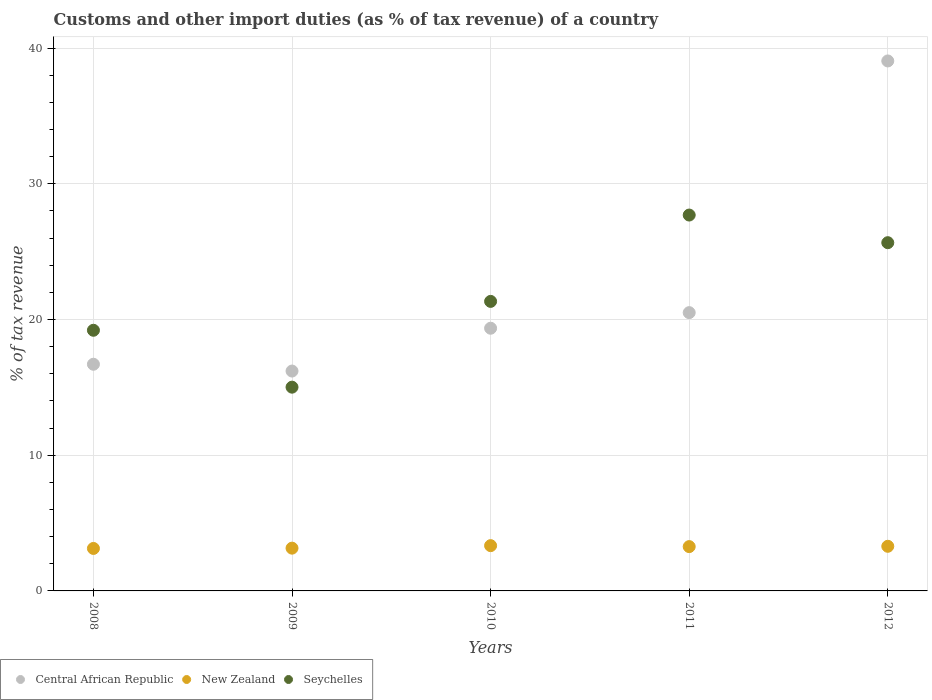How many different coloured dotlines are there?
Provide a succinct answer. 3. Is the number of dotlines equal to the number of legend labels?
Make the answer very short. Yes. What is the percentage of tax revenue from customs in Seychelles in 2011?
Provide a succinct answer. 27.7. Across all years, what is the maximum percentage of tax revenue from customs in New Zealand?
Your answer should be compact. 3.34. Across all years, what is the minimum percentage of tax revenue from customs in Central African Republic?
Provide a short and direct response. 16.2. In which year was the percentage of tax revenue from customs in Central African Republic minimum?
Provide a succinct answer. 2009. What is the total percentage of tax revenue from customs in Seychelles in the graph?
Offer a terse response. 108.92. What is the difference between the percentage of tax revenue from customs in Seychelles in 2010 and that in 2012?
Your answer should be very brief. -4.33. What is the difference between the percentage of tax revenue from customs in Central African Republic in 2010 and the percentage of tax revenue from customs in New Zealand in 2008?
Provide a short and direct response. 16.23. What is the average percentage of tax revenue from customs in Seychelles per year?
Give a very brief answer. 21.78. In the year 2012, what is the difference between the percentage of tax revenue from customs in Central African Republic and percentage of tax revenue from customs in Seychelles?
Provide a succinct answer. 13.39. What is the ratio of the percentage of tax revenue from customs in Central African Republic in 2008 to that in 2011?
Keep it short and to the point. 0.81. What is the difference between the highest and the second highest percentage of tax revenue from customs in Seychelles?
Give a very brief answer. 2.04. What is the difference between the highest and the lowest percentage of tax revenue from customs in Seychelles?
Offer a terse response. 12.68. In how many years, is the percentage of tax revenue from customs in Seychelles greater than the average percentage of tax revenue from customs in Seychelles taken over all years?
Your answer should be very brief. 2. Is the sum of the percentage of tax revenue from customs in New Zealand in 2009 and 2011 greater than the maximum percentage of tax revenue from customs in Seychelles across all years?
Your response must be concise. No. Is it the case that in every year, the sum of the percentage of tax revenue from customs in Seychelles and percentage of tax revenue from customs in New Zealand  is greater than the percentage of tax revenue from customs in Central African Republic?
Give a very brief answer. No. Does the percentage of tax revenue from customs in New Zealand monotonically increase over the years?
Offer a terse response. No. Is the percentage of tax revenue from customs in Central African Republic strictly greater than the percentage of tax revenue from customs in New Zealand over the years?
Ensure brevity in your answer.  Yes. How many dotlines are there?
Your answer should be compact. 3. Does the graph contain any zero values?
Ensure brevity in your answer.  No. Where does the legend appear in the graph?
Your answer should be compact. Bottom left. How are the legend labels stacked?
Your response must be concise. Horizontal. What is the title of the graph?
Your answer should be very brief. Customs and other import duties (as % of tax revenue) of a country. Does "French Polynesia" appear as one of the legend labels in the graph?
Your answer should be compact. No. What is the label or title of the X-axis?
Ensure brevity in your answer.  Years. What is the label or title of the Y-axis?
Your answer should be very brief. % of tax revenue. What is the % of tax revenue of Central African Republic in 2008?
Offer a terse response. 16.7. What is the % of tax revenue of New Zealand in 2008?
Offer a terse response. 3.13. What is the % of tax revenue of Seychelles in 2008?
Make the answer very short. 19.21. What is the % of tax revenue of Central African Republic in 2009?
Give a very brief answer. 16.2. What is the % of tax revenue of New Zealand in 2009?
Your answer should be compact. 3.15. What is the % of tax revenue in Seychelles in 2009?
Offer a terse response. 15.01. What is the % of tax revenue of Central African Republic in 2010?
Your response must be concise. 19.36. What is the % of tax revenue of New Zealand in 2010?
Offer a very short reply. 3.34. What is the % of tax revenue of Seychelles in 2010?
Provide a succinct answer. 21.34. What is the % of tax revenue in Central African Republic in 2011?
Provide a short and direct response. 20.51. What is the % of tax revenue of New Zealand in 2011?
Your answer should be very brief. 3.27. What is the % of tax revenue in Seychelles in 2011?
Your response must be concise. 27.7. What is the % of tax revenue in Central African Republic in 2012?
Provide a succinct answer. 39.05. What is the % of tax revenue in New Zealand in 2012?
Your answer should be compact. 3.29. What is the % of tax revenue in Seychelles in 2012?
Make the answer very short. 25.66. Across all years, what is the maximum % of tax revenue in Central African Republic?
Your answer should be compact. 39.05. Across all years, what is the maximum % of tax revenue in New Zealand?
Your answer should be compact. 3.34. Across all years, what is the maximum % of tax revenue of Seychelles?
Provide a short and direct response. 27.7. Across all years, what is the minimum % of tax revenue in Central African Republic?
Your answer should be very brief. 16.2. Across all years, what is the minimum % of tax revenue in New Zealand?
Provide a short and direct response. 3.13. Across all years, what is the minimum % of tax revenue of Seychelles?
Your answer should be compact. 15.01. What is the total % of tax revenue of Central African Republic in the graph?
Keep it short and to the point. 111.82. What is the total % of tax revenue of New Zealand in the graph?
Your response must be concise. 16.17. What is the total % of tax revenue in Seychelles in the graph?
Ensure brevity in your answer.  108.92. What is the difference between the % of tax revenue in Central African Republic in 2008 and that in 2009?
Your response must be concise. 0.5. What is the difference between the % of tax revenue in New Zealand in 2008 and that in 2009?
Provide a succinct answer. -0.02. What is the difference between the % of tax revenue of Seychelles in 2008 and that in 2009?
Give a very brief answer. 4.19. What is the difference between the % of tax revenue of Central African Republic in 2008 and that in 2010?
Provide a succinct answer. -2.65. What is the difference between the % of tax revenue in New Zealand in 2008 and that in 2010?
Give a very brief answer. -0.21. What is the difference between the % of tax revenue of Seychelles in 2008 and that in 2010?
Your answer should be very brief. -2.13. What is the difference between the % of tax revenue in Central African Republic in 2008 and that in 2011?
Your answer should be compact. -3.8. What is the difference between the % of tax revenue of New Zealand in 2008 and that in 2011?
Provide a short and direct response. -0.14. What is the difference between the % of tax revenue of Seychelles in 2008 and that in 2011?
Your answer should be very brief. -8.49. What is the difference between the % of tax revenue in Central African Republic in 2008 and that in 2012?
Give a very brief answer. -22.35. What is the difference between the % of tax revenue in New Zealand in 2008 and that in 2012?
Ensure brevity in your answer.  -0.16. What is the difference between the % of tax revenue of Seychelles in 2008 and that in 2012?
Offer a very short reply. -6.45. What is the difference between the % of tax revenue in Central African Republic in 2009 and that in 2010?
Provide a short and direct response. -3.16. What is the difference between the % of tax revenue of New Zealand in 2009 and that in 2010?
Offer a terse response. -0.18. What is the difference between the % of tax revenue in Seychelles in 2009 and that in 2010?
Give a very brief answer. -6.32. What is the difference between the % of tax revenue in Central African Republic in 2009 and that in 2011?
Your answer should be compact. -4.3. What is the difference between the % of tax revenue of New Zealand in 2009 and that in 2011?
Offer a very short reply. -0.11. What is the difference between the % of tax revenue of Seychelles in 2009 and that in 2011?
Provide a succinct answer. -12.68. What is the difference between the % of tax revenue in Central African Republic in 2009 and that in 2012?
Make the answer very short. -22.85. What is the difference between the % of tax revenue of New Zealand in 2009 and that in 2012?
Make the answer very short. -0.14. What is the difference between the % of tax revenue in Seychelles in 2009 and that in 2012?
Provide a short and direct response. -10.65. What is the difference between the % of tax revenue of Central African Republic in 2010 and that in 2011?
Ensure brevity in your answer.  -1.15. What is the difference between the % of tax revenue in New Zealand in 2010 and that in 2011?
Your response must be concise. 0.07. What is the difference between the % of tax revenue in Seychelles in 2010 and that in 2011?
Provide a succinct answer. -6.36. What is the difference between the % of tax revenue of Central African Republic in 2010 and that in 2012?
Your response must be concise. -19.7. What is the difference between the % of tax revenue in New Zealand in 2010 and that in 2012?
Offer a very short reply. 0.05. What is the difference between the % of tax revenue in Seychelles in 2010 and that in 2012?
Offer a terse response. -4.33. What is the difference between the % of tax revenue in Central African Republic in 2011 and that in 2012?
Provide a succinct answer. -18.55. What is the difference between the % of tax revenue in New Zealand in 2011 and that in 2012?
Ensure brevity in your answer.  -0.02. What is the difference between the % of tax revenue in Seychelles in 2011 and that in 2012?
Ensure brevity in your answer.  2.04. What is the difference between the % of tax revenue of Central African Republic in 2008 and the % of tax revenue of New Zealand in 2009?
Make the answer very short. 13.55. What is the difference between the % of tax revenue of Central African Republic in 2008 and the % of tax revenue of Seychelles in 2009?
Make the answer very short. 1.69. What is the difference between the % of tax revenue in New Zealand in 2008 and the % of tax revenue in Seychelles in 2009?
Offer a terse response. -11.88. What is the difference between the % of tax revenue in Central African Republic in 2008 and the % of tax revenue in New Zealand in 2010?
Provide a succinct answer. 13.37. What is the difference between the % of tax revenue in Central African Republic in 2008 and the % of tax revenue in Seychelles in 2010?
Offer a very short reply. -4.63. What is the difference between the % of tax revenue of New Zealand in 2008 and the % of tax revenue of Seychelles in 2010?
Offer a terse response. -18.21. What is the difference between the % of tax revenue of Central African Republic in 2008 and the % of tax revenue of New Zealand in 2011?
Give a very brief answer. 13.44. What is the difference between the % of tax revenue in Central African Republic in 2008 and the % of tax revenue in Seychelles in 2011?
Provide a succinct answer. -10.99. What is the difference between the % of tax revenue of New Zealand in 2008 and the % of tax revenue of Seychelles in 2011?
Your response must be concise. -24.57. What is the difference between the % of tax revenue in Central African Republic in 2008 and the % of tax revenue in New Zealand in 2012?
Offer a very short reply. 13.41. What is the difference between the % of tax revenue in Central African Republic in 2008 and the % of tax revenue in Seychelles in 2012?
Provide a succinct answer. -8.96. What is the difference between the % of tax revenue of New Zealand in 2008 and the % of tax revenue of Seychelles in 2012?
Offer a terse response. -22.53. What is the difference between the % of tax revenue of Central African Republic in 2009 and the % of tax revenue of New Zealand in 2010?
Your answer should be very brief. 12.87. What is the difference between the % of tax revenue in Central African Republic in 2009 and the % of tax revenue in Seychelles in 2010?
Make the answer very short. -5.13. What is the difference between the % of tax revenue in New Zealand in 2009 and the % of tax revenue in Seychelles in 2010?
Offer a terse response. -18.18. What is the difference between the % of tax revenue in Central African Republic in 2009 and the % of tax revenue in New Zealand in 2011?
Keep it short and to the point. 12.94. What is the difference between the % of tax revenue of Central African Republic in 2009 and the % of tax revenue of Seychelles in 2011?
Make the answer very short. -11.5. What is the difference between the % of tax revenue of New Zealand in 2009 and the % of tax revenue of Seychelles in 2011?
Your answer should be very brief. -24.55. What is the difference between the % of tax revenue of Central African Republic in 2009 and the % of tax revenue of New Zealand in 2012?
Offer a very short reply. 12.91. What is the difference between the % of tax revenue in Central African Republic in 2009 and the % of tax revenue in Seychelles in 2012?
Your answer should be very brief. -9.46. What is the difference between the % of tax revenue in New Zealand in 2009 and the % of tax revenue in Seychelles in 2012?
Provide a succinct answer. -22.51. What is the difference between the % of tax revenue of Central African Republic in 2010 and the % of tax revenue of New Zealand in 2011?
Your answer should be very brief. 16.09. What is the difference between the % of tax revenue of Central African Republic in 2010 and the % of tax revenue of Seychelles in 2011?
Your answer should be compact. -8.34. What is the difference between the % of tax revenue of New Zealand in 2010 and the % of tax revenue of Seychelles in 2011?
Keep it short and to the point. -24.36. What is the difference between the % of tax revenue in Central African Republic in 2010 and the % of tax revenue in New Zealand in 2012?
Give a very brief answer. 16.07. What is the difference between the % of tax revenue in Central African Republic in 2010 and the % of tax revenue in Seychelles in 2012?
Your answer should be compact. -6.3. What is the difference between the % of tax revenue in New Zealand in 2010 and the % of tax revenue in Seychelles in 2012?
Your response must be concise. -22.33. What is the difference between the % of tax revenue of Central African Republic in 2011 and the % of tax revenue of New Zealand in 2012?
Provide a succinct answer. 17.22. What is the difference between the % of tax revenue in Central African Republic in 2011 and the % of tax revenue in Seychelles in 2012?
Give a very brief answer. -5.15. What is the difference between the % of tax revenue of New Zealand in 2011 and the % of tax revenue of Seychelles in 2012?
Offer a very short reply. -22.4. What is the average % of tax revenue in Central African Republic per year?
Give a very brief answer. 22.36. What is the average % of tax revenue in New Zealand per year?
Offer a very short reply. 3.23. What is the average % of tax revenue in Seychelles per year?
Provide a succinct answer. 21.78. In the year 2008, what is the difference between the % of tax revenue in Central African Republic and % of tax revenue in New Zealand?
Provide a succinct answer. 13.57. In the year 2008, what is the difference between the % of tax revenue of Central African Republic and % of tax revenue of Seychelles?
Your answer should be very brief. -2.5. In the year 2008, what is the difference between the % of tax revenue of New Zealand and % of tax revenue of Seychelles?
Make the answer very short. -16.08. In the year 2009, what is the difference between the % of tax revenue of Central African Republic and % of tax revenue of New Zealand?
Ensure brevity in your answer.  13.05. In the year 2009, what is the difference between the % of tax revenue in Central African Republic and % of tax revenue in Seychelles?
Give a very brief answer. 1.19. In the year 2009, what is the difference between the % of tax revenue in New Zealand and % of tax revenue in Seychelles?
Ensure brevity in your answer.  -11.86. In the year 2010, what is the difference between the % of tax revenue of Central African Republic and % of tax revenue of New Zealand?
Your answer should be compact. 16.02. In the year 2010, what is the difference between the % of tax revenue in Central African Republic and % of tax revenue in Seychelles?
Ensure brevity in your answer.  -1.98. In the year 2010, what is the difference between the % of tax revenue of New Zealand and % of tax revenue of Seychelles?
Give a very brief answer. -18. In the year 2011, what is the difference between the % of tax revenue of Central African Republic and % of tax revenue of New Zealand?
Your answer should be very brief. 17.24. In the year 2011, what is the difference between the % of tax revenue in Central African Republic and % of tax revenue in Seychelles?
Offer a very short reply. -7.19. In the year 2011, what is the difference between the % of tax revenue in New Zealand and % of tax revenue in Seychelles?
Provide a short and direct response. -24.43. In the year 2012, what is the difference between the % of tax revenue of Central African Republic and % of tax revenue of New Zealand?
Offer a terse response. 35.76. In the year 2012, what is the difference between the % of tax revenue in Central African Republic and % of tax revenue in Seychelles?
Your answer should be compact. 13.39. In the year 2012, what is the difference between the % of tax revenue in New Zealand and % of tax revenue in Seychelles?
Keep it short and to the point. -22.37. What is the ratio of the % of tax revenue of Central African Republic in 2008 to that in 2009?
Give a very brief answer. 1.03. What is the ratio of the % of tax revenue of New Zealand in 2008 to that in 2009?
Give a very brief answer. 0.99. What is the ratio of the % of tax revenue of Seychelles in 2008 to that in 2009?
Your answer should be very brief. 1.28. What is the ratio of the % of tax revenue of Central African Republic in 2008 to that in 2010?
Your response must be concise. 0.86. What is the ratio of the % of tax revenue of New Zealand in 2008 to that in 2010?
Provide a short and direct response. 0.94. What is the ratio of the % of tax revenue in Seychelles in 2008 to that in 2010?
Keep it short and to the point. 0.9. What is the ratio of the % of tax revenue in Central African Republic in 2008 to that in 2011?
Give a very brief answer. 0.81. What is the ratio of the % of tax revenue in New Zealand in 2008 to that in 2011?
Provide a succinct answer. 0.96. What is the ratio of the % of tax revenue of Seychelles in 2008 to that in 2011?
Give a very brief answer. 0.69. What is the ratio of the % of tax revenue in Central African Republic in 2008 to that in 2012?
Make the answer very short. 0.43. What is the ratio of the % of tax revenue of New Zealand in 2008 to that in 2012?
Your answer should be compact. 0.95. What is the ratio of the % of tax revenue of Seychelles in 2008 to that in 2012?
Make the answer very short. 0.75. What is the ratio of the % of tax revenue in Central African Republic in 2009 to that in 2010?
Your answer should be compact. 0.84. What is the ratio of the % of tax revenue of New Zealand in 2009 to that in 2010?
Provide a succinct answer. 0.94. What is the ratio of the % of tax revenue of Seychelles in 2009 to that in 2010?
Offer a terse response. 0.7. What is the ratio of the % of tax revenue of Central African Republic in 2009 to that in 2011?
Your answer should be very brief. 0.79. What is the ratio of the % of tax revenue of New Zealand in 2009 to that in 2011?
Your response must be concise. 0.97. What is the ratio of the % of tax revenue in Seychelles in 2009 to that in 2011?
Ensure brevity in your answer.  0.54. What is the ratio of the % of tax revenue of Central African Republic in 2009 to that in 2012?
Give a very brief answer. 0.41. What is the ratio of the % of tax revenue of New Zealand in 2009 to that in 2012?
Keep it short and to the point. 0.96. What is the ratio of the % of tax revenue in Seychelles in 2009 to that in 2012?
Provide a succinct answer. 0.59. What is the ratio of the % of tax revenue of Central African Republic in 2010 to that in 2011?
Offer a terse response. 0.94. What is the ratio of the % of tax revenue in New Zealand in 2010 to that in 2011?
Offer a terse response. 1.02. What is the ratio of the % of tax revenue in Seychelles in 2010 to that in 2011?
Keep it short and to the point. 0.77. What is the ratio of the % of tax revenue in Central African Republic in 2010 to that in 2012?
Your response must be concise. 0.5. What is the ratio of the % of tax revenue of New Zealand in 2010 to that in 2012?
Your answer should be compact. 1.01. What is the ratio of the % of tax revenue of Seychelles in 2010 to that in 2012?
Provide a succinct answer. 0.83. What is the ratio of the % of tax revenue of Central African Republic in 2011 to that in 2012?
Keep it short and to the point. 0.53. What is the ratio of the % of tax revenue in New Zealand in 2011 to that in 2012?
Your answer should be compact. 0.99. What is the ratio of the % of tax revenue in Seychelles in 2011 to that in 2012?
Provide a succinct answer. 1.08. What is the difference between the highest and the second highest % of tax revenue in Central African Republic?
Provide a short and direct response. 18.55. What is the difference between the highest and the second highest % of tax revenue in New Zealand?
Your answer should be compact. 0.05. What is the difference between the highest and the second highest % of tax revenue of Seychelles?
Offer a terse response. 2.04. What is the difference between the highest and the lowest % of tax revenue of Central African Republic?
Your answer should be compact. 22.85. What is the difference between the highest and the lowest % of tax revenue in New Zealand?
Make the answer very short. 0.21. What is the difference between the highest and the lowest % of tax revenue in Seychelles?
Offer a terse response. 12.68. 